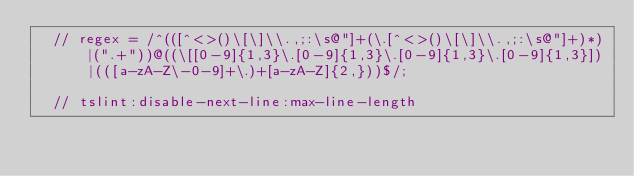<code> <loc_0><loc_0><loc_500><loc_500><_TypeScript_>  // regex = /^(([^<>()\[\]\\.,;:\s@"]+(\.[^<>()\[\]\\.,;:\s@"]+)*)|(".+"))@((\[[0-9]{1,3}\.[0-9]{1,3}\.[0-9]{1,3}\.[0-9]{1,3}])|(([a-zA-Z\-0-9]+\.)+[a-zA-Z]{2,}))$/;

  // tslint:disable-next-line:max-line-length</code> 